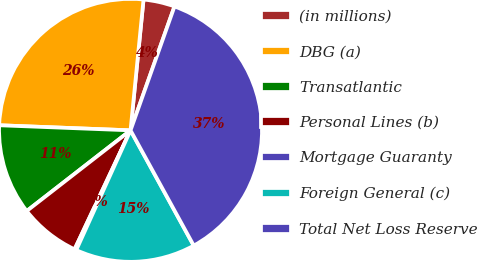Convert chart to OTSL. <chart><loc_0><loc_0><loc_500><loc_500><pie_chart><fcel>(in millions)<fcel>DBG (a)<fcel>Transatlantic<fcel>Personal Lines (b)<fcel>Mortgage Guaranty<fcel>Foreign General (c)<fcel>Total Net Loss Reserve<nl><fcel>3.85%<fcel>25.96%<fcel>11.13%<fcel>7.49%<fcel>0.22%<fcel>14.76%<fcel>36.59%<nl></chart> 